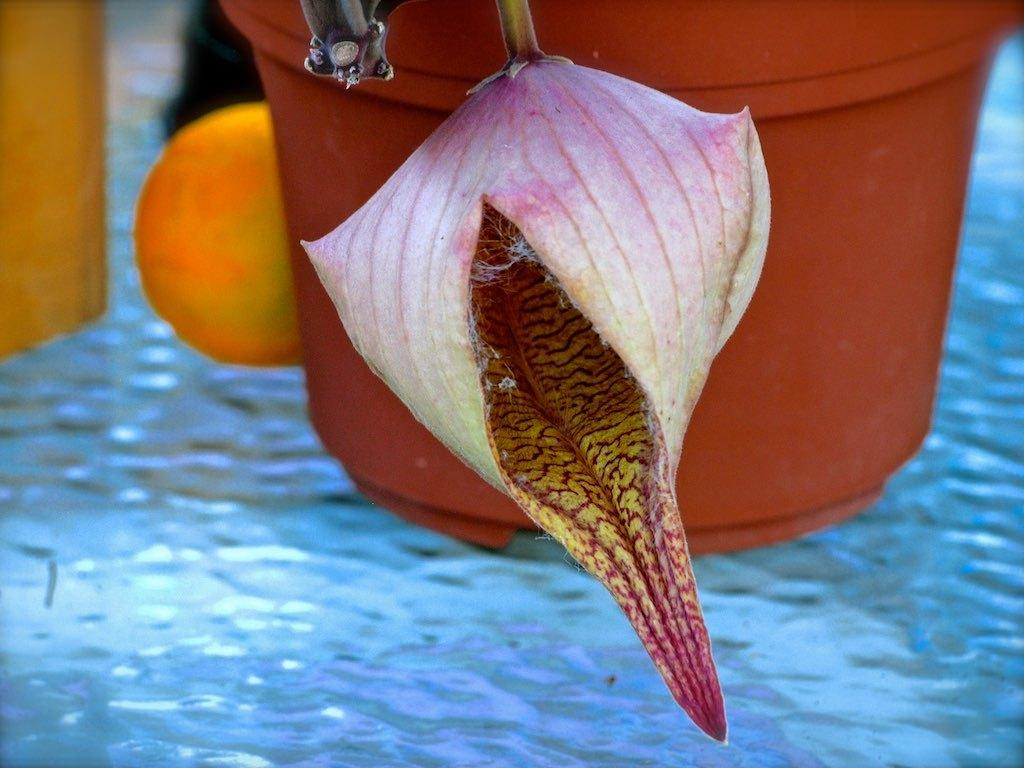What is the primary element visible in the image? There is water in the image. What type of container is present in the image? There is a flower pot in the image. What stage of growth is the flower in the image? There is a flower bud in the image. What connects the flower bud to the flower pot? There are stems in the image. What else can be seen in the image besides the water and flower? There are objects in the image. What type of linen is draped over the objects in the image? There is no linen present in the image; it only features water, a flower pot, a flower bud, stems, and other objects. 